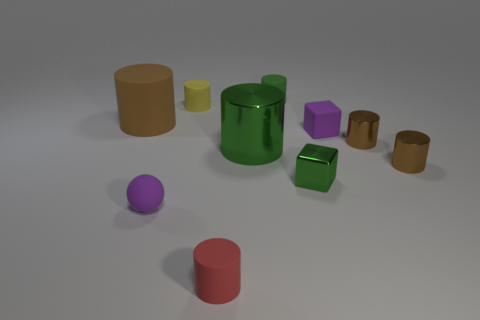What size is the cylinder in front of the green metallic object that is in front of the large green cylinder?
Give a very brief answer. Small. Is the number of yellow matte cylinders that are left of the big rubber thing greater than the number of tiny yellow cylinders that are behind the tiny green rubber cylinder?
Keep it short and to the point. No. How many cylinders are either red things or purple things?
Make the answer very short. 1. There is a small purple object to the right of the tiny yellow matte object; does it have the same shape as the big brown matte object?
Keep it short and to the point. No. What is the color of the small ball?
Keep it short and to the point. Purple. What color is the other big rubber thing that is the same shape as the red thing?
Provide a succinct answer. Brown. How many tiny green objects have the same shape as the large green shiny object?
Ensure brevity in your answer.  1. How many objects are either small green blocks or tiny rubber objects left of the tiny purple cube?
Provide a short and direct response. 5. There is a large metal object; does it have the same color as the matte cylinder in front of the metallic block?
Your answer should be compact. No. There is a cylinder that is both in front of the green shiny cylinder and to the left of the tiny green matte cylinder; how big is it?
Offer a very short reply. Small. 